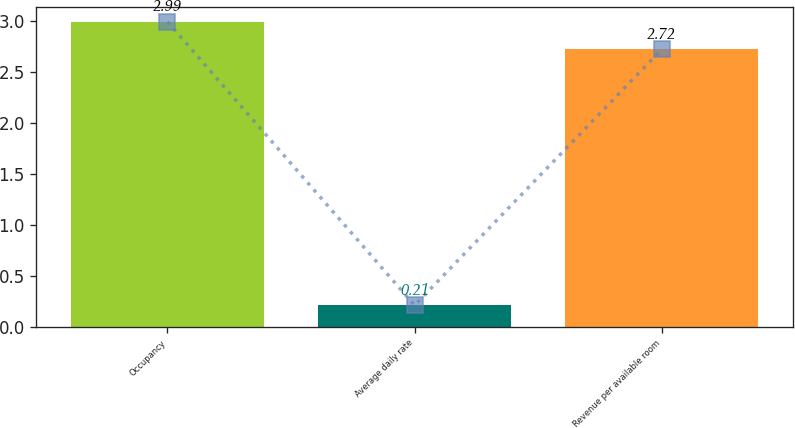Convert chart. <chart><loc_0><loc_0><loc_500><loc_500><bar_chart><fcel>Occupancy<fcel>Average daily rate<fcel>Revenue per available room<nl><fcel>2.99<fcel>0.21<fcel>2.72<nl></chart> 